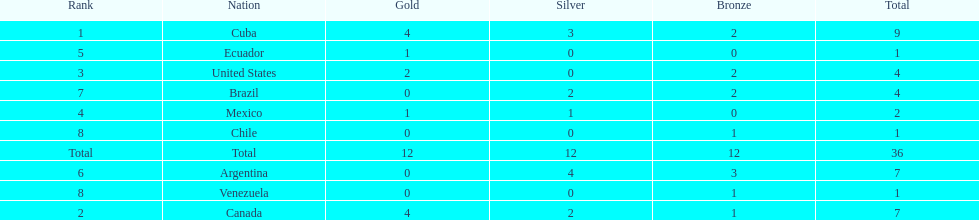Which nation won gold but did not win silver? United States. 